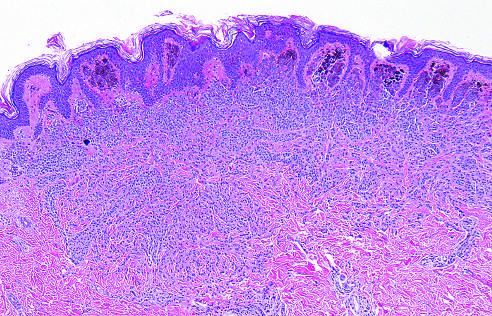what is composed of melanocytes that lose pigmentation and become smaller and more dispersed as they extend into the dermis-all signs that speak to the benign nature of the proliferation?
Answer the question using a single word or phrase. The nevus 